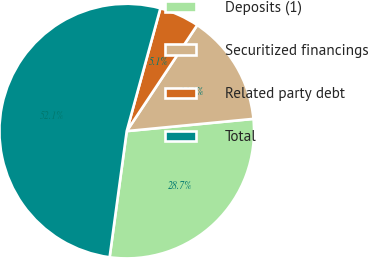Convert chart to OTSL. <chart><loc_0><loc_0><loc_500><loc_500><pie_chart><fcel>Deposits (1)<fcel>Securitized financings<fcel>Related party debt<fcel>Total<nl><fcel>28.68%<fcel>14.13%<fcel>5.08%<fcel>52.11%<nl></chart> 